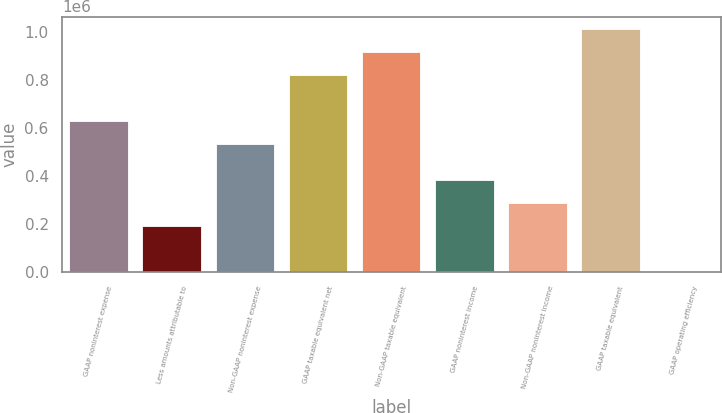Convert chart. <chart><loc_0><loc_0><loc_500><loc_500><bar_chart><fcel>GAAP noninterest expense<fcel>Less amounts attributable to<fcel>Non-GAAP noninterest expense<fcel>GAAP taxable equivalent net<fcel>Non-GAAP taxable equivalent<fcel>GAAP noninterest income<fcel>Non-GAAP noninterest income<fcel>GAAP taxable equivalent<fcel>GAAP operating efficiency<nl><fcel>630189<fcel>191112<fcel>534662<fcel>821244<fcel>916771<fcel>382166<fcel>286639<fcel>1.0123e+06<fcel>57.15<nl></chart> 